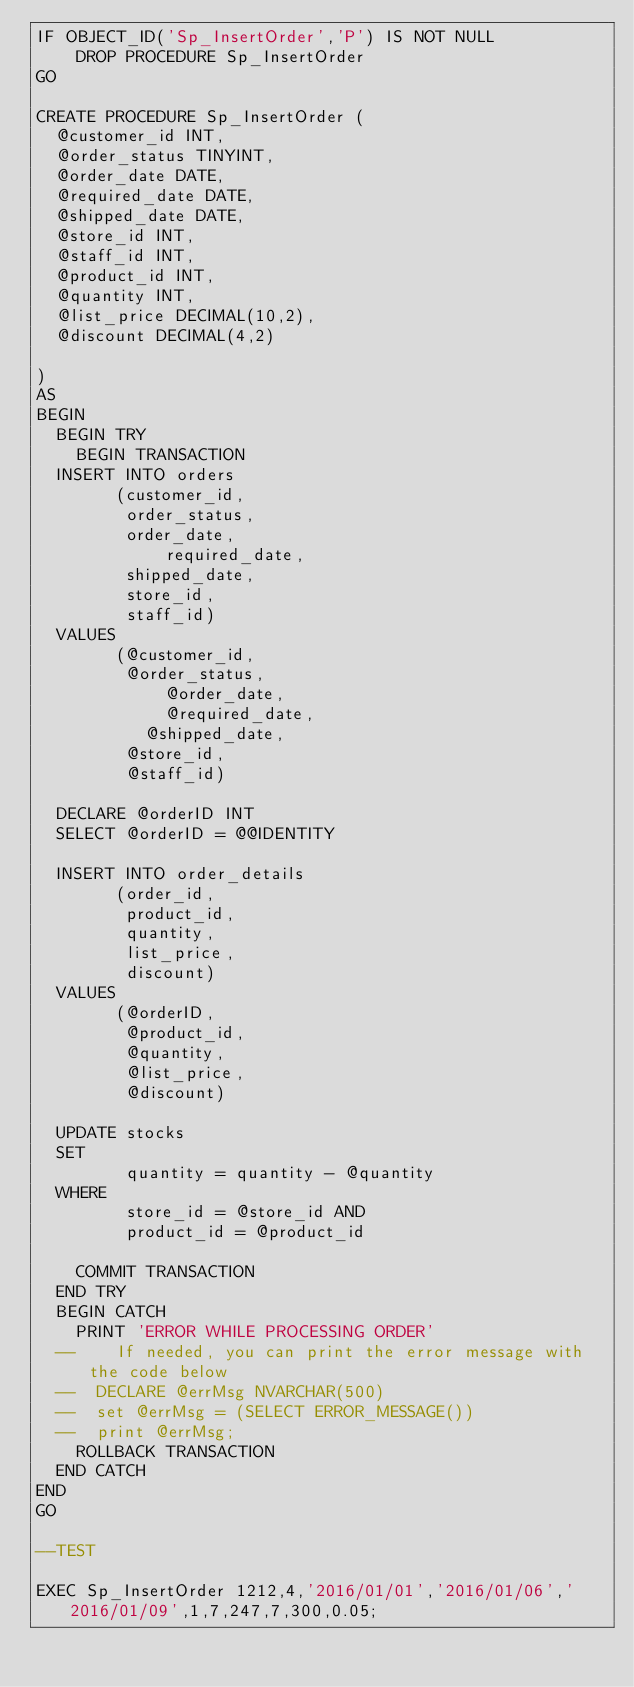Convert code to text. <code><loc_0><loc_0><loc_500><loc_500><_SQL_>IF OBJECT_ID('Sp_InsertOrder','P') IS NOT NULL
    DROP PROCEDURE Sp_InsertOrder
GO

CREATE PROCEDURE Sp_InsertOrder (
	@customer_id INT,
	@order_status TINYINT,
	@order_date DATE,
	@required_date DATE,
	@shipped_date DATE,
	@store_id INT,
	@staff_id INT,
	@product_id INT,
	@quantity INT,
	@list_price DECIMAL(10,2),
	@discount DECIMAL(4,2)

)
AS
BEGIN
	BEGIN TRY
		BEGIN TRANSACTION
	INSERT INTO orders 
				(customer_id,
				 order_status,
				 order_date,
			     	 required_date,
				 shipped_date,
				 store_id,
				 staff_id)
	VALUES
				(@customer_id,
				 @order_status,
			    	 @order_date,
			    	 @required_date,
			   	 @shipped_date,
				 @store_id,
				 @staff_id)
				 
	DECLARE @orderID INT
	SELECT @orderID = @@IDENTITY

	INSERT INTO order_details 
				(order_id,
				 product_id,
				 quantity,
				 list_price,
				 discount)
	VALUES
				(@orderID,
				 @product_id,
				 @quantity,
				 @list_price,
				 @discount)

	UPDATE stocks
	SET
				 quantity = quantity - @quantity
	WHERE
				 store_id = @store_id AND
				 product_id = @product_id
				 
		COMMIT TRANSACTION
	END TRY
	BEGIN CATCH 
		PRINT 'ERROR WHILE PROCESSING ORDER'
	--  	If needed, you can print the error message with the code below
	--	DECLARE @errMsg NVARCHAR(500)
	--	set @errMsg = (SELECT ERROR_MESSAGE())
	--	print @errMsg;
		ROLLBACK TRANSACTION
	END CATCH	
END
GO

--TEST

EXEC Sp_InsertOrder 1212,4,'2016/01/01','2016/01/06','2016/01/09',1,7,247,7,300,0.05;
</code> 